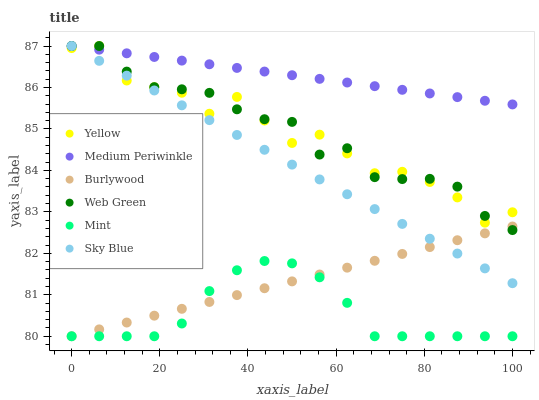Does Mint have the minimum area under the curve?
Answer yes or no. Yes. Does Medium Periwinkle have the maximum area under the curve?
Answer yes or no. Yes. Does Web Green have the minimum area under the curve?
Answer yes or no. No. Does Web Green have the maximum area under the curve?
Answer yes or no. No. Is Burlywood the smoothest?
Answer yes or no. Yes. Is Yellow the roughest?
Answer yes or no. Yes. Is Medium Periwinkle the smoothest?
Answer yes or no. No. Is Medium Periwinkle the roughest?
Answer yes or no. No. Does Burlywood have the lowest value?
Answer yes or no. Yes. Does Web Green have the lowest value?
Answer yes or no. No. Does Sky Blue have the highest value?
Answer yes or no. Yes. Does Mint have the highest value?
Answer yes or no. No. Is Burlywood less than Yellow?
Answer yes or no. Yes. Is Medium Periwinkle greater than Burlywood?
Answer yes or no. Yes. Does Yellow intersect Web Green?
Answer yes or no. Yes. Is Yellow less than Web Green?
Answer yes or no. No. Is Yellow greater than Web Green?
Answer yes or no. No. Does Burlywood intersect Yellow?
Answer yes or no. No. 